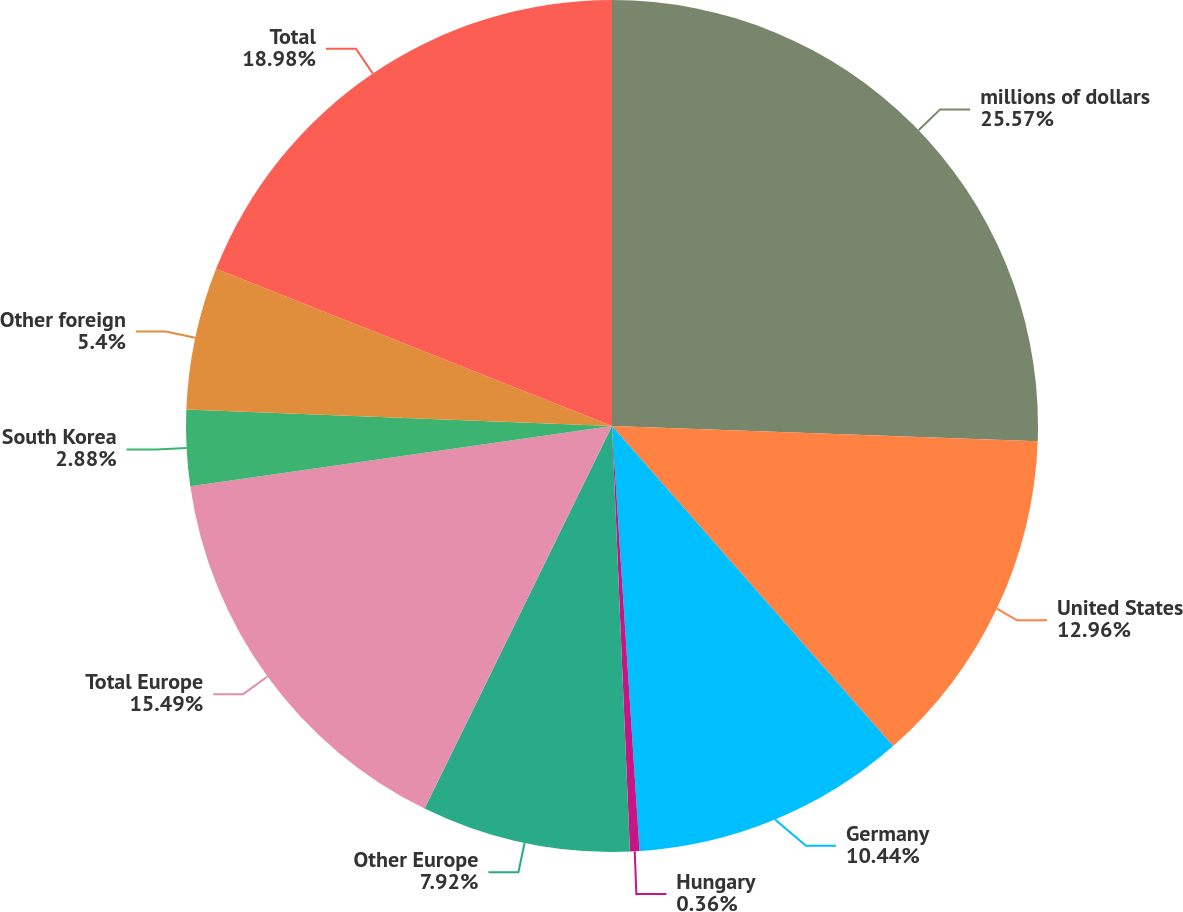Convert chart to OTSL. <chart><loc_0><loc_0><loc_500><loc_500><pie_chart><fcel>millions of dollars<fcel>United States<fcel>Germany<fcel>Hungary<fcel>Other Europe<fcel>Total Europe<fcel>South Korea<fcel>Other foreign<fcel>Total<nl><fcel>25.57%<fcel>12.96%<fcel>10.44%<fcel>0.36%<fcel>7.92%<fcel>15.49%<fcel>2.88%<fcel>5.4%<fcel>18.98%<nl></chart> 